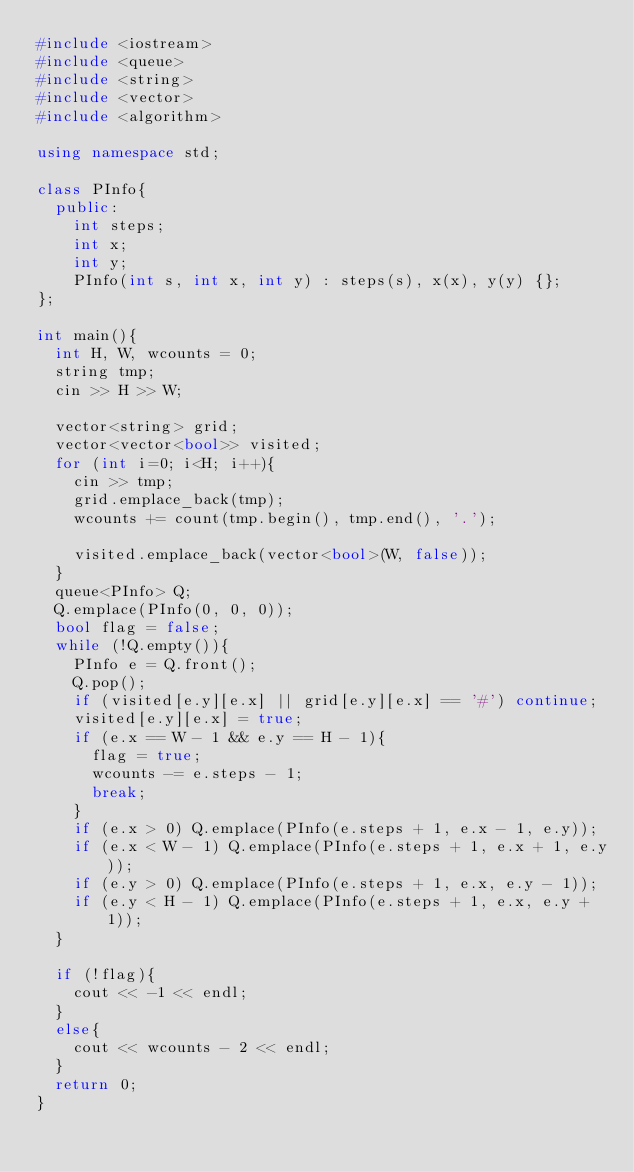Convert code to text. <code><loc_0><loc_0><loc_500><loc_500><_C++_>#include <iostream>
#include <queue>
#include <string>
#include <vector>
#include <algorithm>

using namespace std;

class PInfo{
  public:
  	int steps;
  	int x;
  	int y;
  	PInfo(int s, int x, int y) : steps(s), x(x), y(y) {};
};

int main(){
  int H, W, wcounts = 0;
  string tmp;
  cin >> H >> W;
  
  vector<string> grid;
  vector<vector<bool>> visited;
  for (int i=0; i<H; i++){
    cin >> tmp;
    grid.emplace_back(tmp);
    wcounts += count(tmp.begin(), tmp.end(), '.');
    
    visited.emplace_back(vector<bool>(W, false));
  }
  queue<PInfo> Q;
  Q.emplace(PInfo(0, 0, 0));
  bool flag = false;
  while (!Q.empty()){
    PInfo e = Q.front();
    Q.pop();
    if (visited[e.y][e.x] || grid[e.y][e.x] == '#') continue;
    visited[e.y][e.x] = true;
    if (e.x == W - 1 && e.y == H - 1){
      flag = true;
      wcounts -= e.steps - 1;
      break;
    }
    if (e.x > 0) Q.emplace(PInfo(e.steps + 1, e.x - 1, e.y));
    if (e.x < W - 1) Q.emplace(PInfo(e.steps + 1, e.x + 1, e.y));
    if (e.y > 0) Q.emplace(PInfo(e.steps + 1, e.x, e.y - 1));
    if (e.y < H - 1) Q.emplace(PInfo(e.steps + 1, e.x, e.y + 1));
  }
  
  if (!flag){
    cout << -1 << endl;
  }
  else{
    cout << wcounts - 2 << endl;
  }
  return 0;
}</code> 